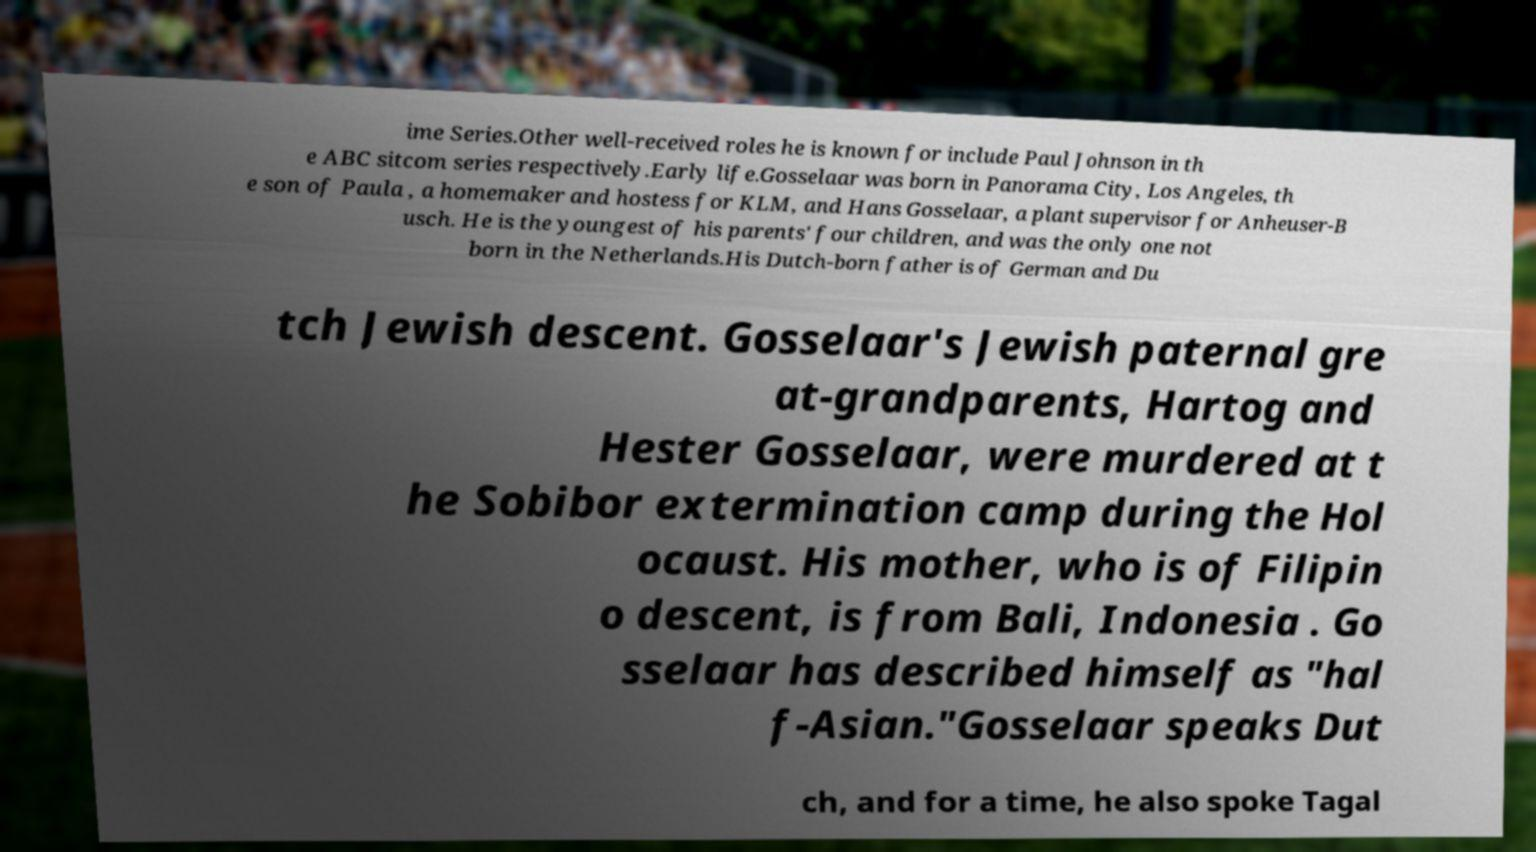Please read and relay the text visible in this image. What does it say? ime Series.Other well-received roles he is known for include Paul Johnson in th e ABC sitcom series respectively.Early life.Gosselaar was born in Panorama City, Los Angeles, th e son of Paula , a homemaker and hostess for KLM, and Hans Gosselaar, a plant supervisor for Anheuser-B usch. He is the youngest of his parents' four children, and was the only one not born in the Netherlands.His Dutch-born father is of German and Du tch Jewish descent. Gosselaar's Jewish paternal gre at-grandparents, Hartog and Hester Gosselaar, were murdered at t he Sobibor extermination camp during the Hol ocaust. His mother, who is of Filipin o descent, is from Bali, Indonesia . Go sselaar has described himself as "hal f-Asian."Gosselaar speaks Dut ch, and for a time, he also spoke Tagal 